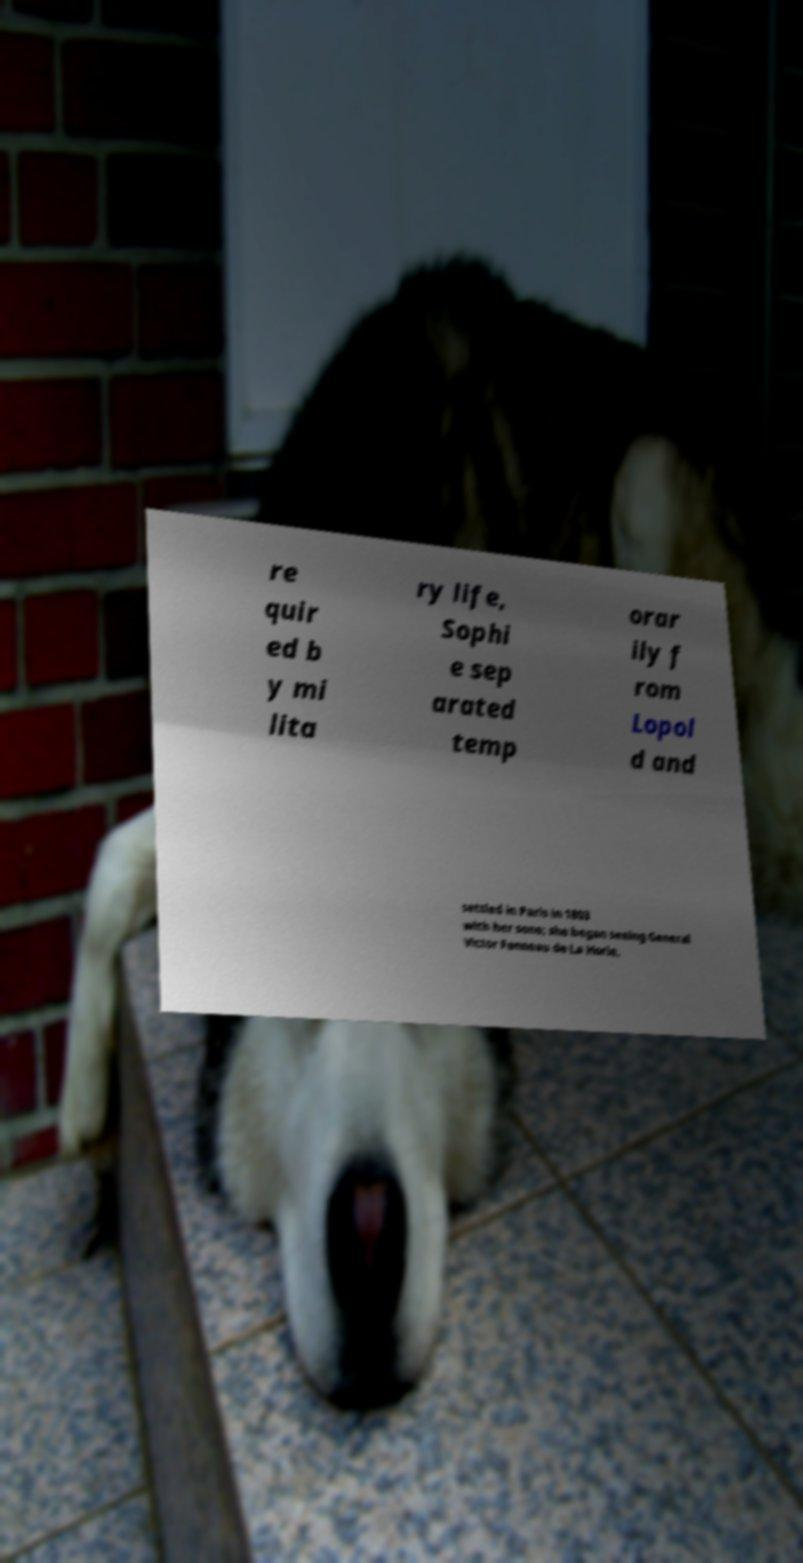Can you accurately transcribe the text from the provided image for me? re quir ed b y mi lita ry life, Sophi e sep arated temp orar ily f rom Lopol d and settled in Paris in 1803 with her sons; she began seeing General Victor Fanneau de La Horie, 